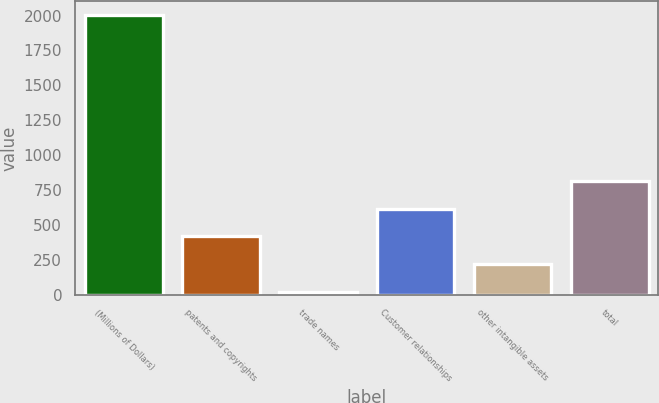<chart> <loc_0><loc_0><loc_500><loc_500><bar_chart><fcel>(Millions of Dollars)<fcel>patents and copyrights<fcel>trade names<fcel>Customer relationships<fcel>other intangible assets<fcel>total<nl><fcel>2005<fcel>420.36<fcel>24.2<fcel>618.44<fcel>222.28<fcel>816.52<nl></chart> 